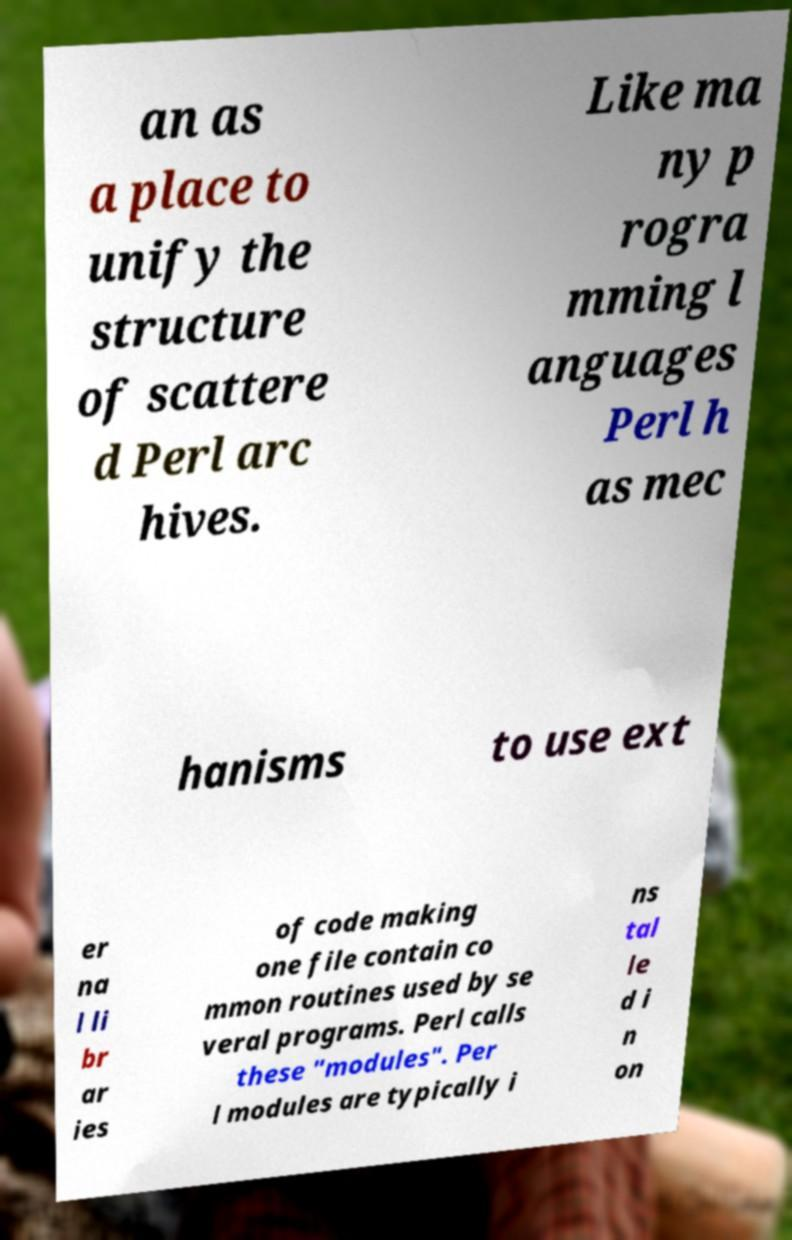What messages or text are displayed in this image? I need them in a readable, typed format. an as a place to unify the structure of scattere d Perl arc hives. Like ma ny p rogra mming l anguages Perl h as mec hanisms to use ext er na l li br ar ies of code making one file contain co mmon routines used by se veral programs. Perl calls these "modules". Per l modules are typically i ns tal le d i n on 